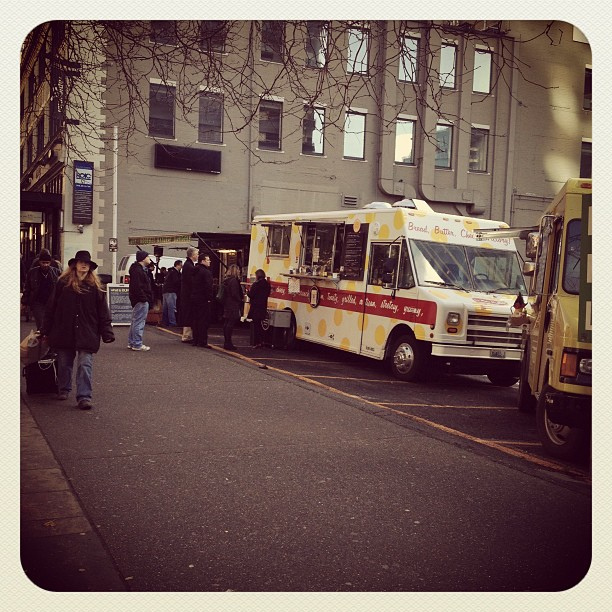What type of food might these trucks be selling? Judging by the signage and the overall setting, it's reasonable to speculate that these food trucks could be selling a variety of street food, such as sandwiches, snacks, or perhaps some local specialties. Is there anything in the image that suggests the time of day or year? The individuals are wearing coats and the trees are bare, suggesting it could be a chilly day, possibly during late autumn or winter. The light also has a softness to it which might indicate it's either early morning or later in the afternoon. 